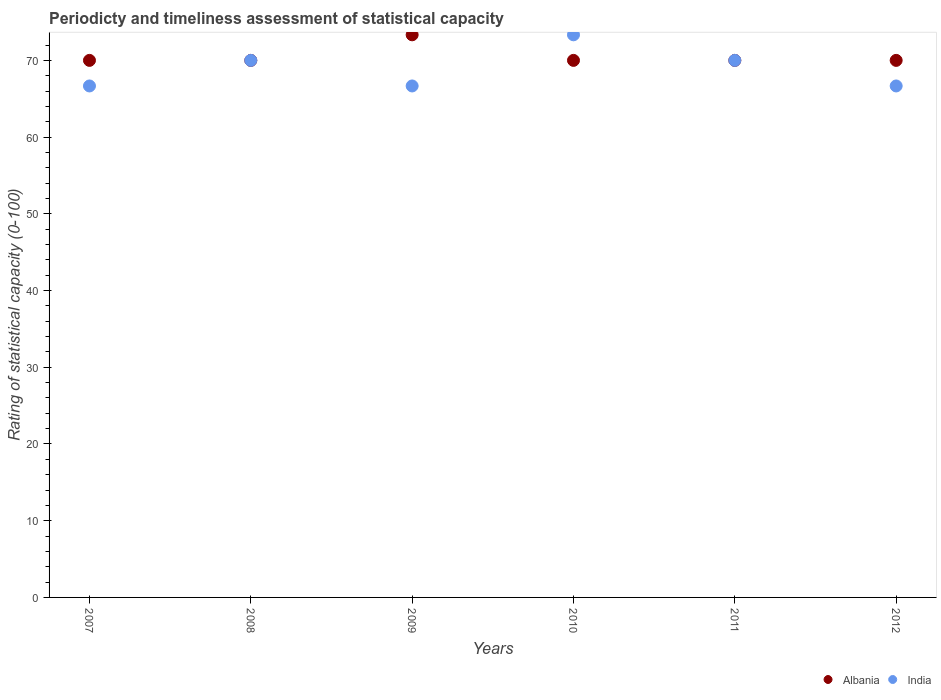Is the number of dotlines equal to the number of legend labels?
Offer a terse response. Yes. What is the rating of statistical capacity in Albania in 2011?
Give a very brief answer. 70. Across all years, what is the maximum rating of statistical capacity in India?
Offer a very short reply. 73.33. What is the total rating of statistical capacity in Albania in the graph?
Make the answer very short. 423.33. What is the difference between the rating of statistical capacity in Albania in 2009 and that in 2010?
Offer a terse response. 3.33. What is the difference between the rating of statistical capacity in Albania in 2012 and the rating of statistical capacity in India in 2009?
Your answer should be compact. 3.33. What is the average rating of statistical capacity in Albania per year?
Make the answer very short. 70.56. In the year 2012, what is the difference between the rating of statistical capacity in India and rating of statistical capacity in Albania?
Ensure brevity in your answer.  -3.33. What is the difference between the highest and the second highest rating of statistical capacity in Albania?
Your answer should be compact. 3.33. What is the difference between the highest and the lowest rating of statistical capacity in India?
Keep it short and to the point. 6.67. In how many years, is the rating of statistical capacity in Albania greater than the average rating of statistical capacity in Albania taken over all years?
Offer a terse response. 1. Is the sum of the rating of statistical capacity in Albania in 2010 and 2011 greater than the maximum rating of statistical capacity in India across all years?
Your answer should be very brief. Yes. Is the rating of statistical capacity in India strictly greater than the rating of statistical capacity in Albania over the years?
Provide a succinct answer. No. How many dotlines are there?
Ensure brevity in your answer.  2. How many years are there in the graph?
Ensure brevity in your answer.  6. What is the difference between two consecutive major ticks on the Y-axis?
Offer a very short reply. 10. Where does the legend appear in the graph?
Your response must be concise. Bottom right. How many legend labels are there?
Your answer should be compact. 2. How are the legend labels stacked?
Your answer should be compact. Horizontal. What is the title of the graph?
Make the answer very short. Periodicty and timeliness assessment of statistical capacity. Does "Zimbabwe" appear as one of the legend labels in the graph?
Provide a short and direct response. No. What is the label or title of the Y-axis?
Ensure brevity in your answer.  Rating of statistical capacity (0-100). What is the Rating of statistical capacity (0-100) in Albania in 2007?
Your answer should be compact. 70. What is the Rating of statistical capacity (0-100) of India in 2007?
Ensure brevity in your answer.  66.67. What is the Rating of statistical capacity (0-100) in India in 2008?
Offer a terse response. 70. What is the Rating of statistical capacity (0-100) in Albania in 2009?
Your response must be concise. 73.33. What is the Rating of statistical capacity (0-100) in India in 2009?
Give a very brief answer. 66.67. What is the Rating of statistical capacity (0-100) in India in 2010?
Make the answer very short. 73.33. What is the Rating of statistical capacity (0-100) of Albania in 2011?
Your response must be concise. 70. What is the Rating of statistical capacity (0-100) of India in 2011?
Provide a short and direct response. 70. What is the Rating of statistical capacity (0-100) of Albania in 2012?
Provide a short and direct response. 70. What is the Rating of statistical capacity (0-100) of India in 2012?
Give a very brief answer. 66.67. Across all years, what is the maximum Rating of statistical capacity (0-100) of Albania?
Make the answer very short. 73.33. Across all years, what is the maximum Rating of statistical capacity (0-100) in India?
Provide a succinct answer. 73.33. Across all years, what is the minimum Rating of statistical capacity (0-100) in India?
Offer a very short reply. 66.67. What is the total Rating of statistical capacity (0-100) in Albania in the graph?
Offer a very short reply. 423.33. What is the total Rating of statistical capacity (0-100) in India in the graph?
Your response must be concise. 413.33. What is the difference between the Rating of statistical capacity (0-100) in Albania in 2007 and that in 2008?
Provide a short and direct response. 0. What is the difference between the Rating of statistical capacity (0-100) in India in 2007 and that in 2008?
Make the answer very short. -3.33. What is the difference between the Rating of statistical capacity (0-100) in Albania in 2007 and that in 2009?
Make the answer very short. -3.33. What is the difference between the Rating of statistical capacity (0-100) in India in 2007 and that in 2009?
Give a very brief answer. 0. What is the difference between the Rating of statistical capacity (0-100) of Albania in 2007 and that in 2010?
Your answer should be compact. 0. What is the difference between the Rating of statistical capacity (0-100) in India in 2007 and that in 2010?
Your answer should be very brief. -6.67. What is the difference between the Rating of statistical capacity (0-100) of Albania in 2007 and that in 2011?
Your answer should be compact. 0. What is the difference between the Rating of statistical capacity (0-100) of Albania in 2007 and that in 2012?
Offer a very short reply. 0. What is the difference between the Rating of statistical capacity (0-100) of India in 2007 and that in 2012?
Your answer should be very brief. 0. What is the difference between the Rating of statistical capacity (0-100) in India in 2008 and that in 2009?
Your answer should be compact. 3.33. What is the difference between the Rating of statistical capacity (0-100) in Albania in 2008 and that in 2011?
Offer a very short reply. 0. What is the difference between the Rating of statistical capacity (0-100) of India in 2008 and that in 2011?
Provide a succinct answer. 0. What is the difference between the Rating of statistical capacity (0-100) of Albania in 2008 and that in 2012?
Ensure brevity in your answer.  0. What is the difference between the Rating of statistical capacity (0-100) of India in 2009 and that in 2010?
Give a very brief answer. -6.67. What is the difference between the Rating of statistical capacity (0-100) of Albania in 2009 and that in 2011?
Give a very brief answer. 3.33. What is the difference between the Rating of statistical capacity (0-100) in India in 2009 and that in 2011?
Offer a very short reply. -3.33. What is the difference between the Rating of statistical capacity (0-100) of Albania in 2009 and that in 2012?
Provide a short and direct response. 3.33. What is the difference between the Rating of statistical capacity (0-100) in India in 2009 and that in 2012?
Provide a short and direct response. 0. What is the difference between the Rating of statistical capacity (0-100) in Albania in 2010 and that in 2012?
Make the answer very short. 0. What is the difference between the Rating of statistical capacity (0-100) in India in 2010 and that in 2012?
Your answer should be compact. 6.67. What is the difference between the Rating of statistical capacity (0-100) in Albania in 2007 and the Rating of statistical capacity (0-100) in India in 2008?
Offer a very short reply. 0. What is the difference between the Rating of statistical capacity (0-100) of Albania in 2007 and the Rating of statistical capacity (0-100) of India in 2009?
Your answer should be very brief. 3.33. What is the difference between the Rating of statistical capacity (0-100) of Albania in 2007 and the Rating of statistical capacity (0-100) of India in 2010?
Offer a terse response. -3.33. What is the difference between the Rating of statistical capacity (0-100) of Albania in 2007 and the Rating of statistical capacity (0-100) of India in 2011?
Your answer should be very brief. 0. What is the difference between the Rating of statistical capacity (0-100) of Albania in 2008 and the Rating of statistical capacity (0-100) of India in 2009?
Your answer should be compact. 3.33. What is the difference between the Rating of statistical capacity (0-100) in Albania in 2008 and the Rating of statistical capacity (0-100) in India in 2010?
Keep it short and to the point. -3.33. What is the difference between the Rating of statistical capacity (0-100) of Albania in 2009 and the Rating of statistical capacity (0-100) of India in 2011?
Your answer should be compact. 3.33. What is the difference between the Rating of statistical capacity (0-100) of Albania in 2010 and the Rating of statistical capacity (0-100) of India in 2012?
Your answer should be compact. 3.33. What is the average Rating of statistical capacity (0-100) in Albania per year?
Offer a very short reply. 70.56. What is the average Rating of statistical capacity (0-100) in India per year?
Ensure brevity in your answer.  68.89. In the year 2007, what is the difference between the Rating of statistical capacity (0-100) in Albania and Rating of statistical capacity (0-100) in India?
Provide a short and direct response. 3.33. In the year 2008, what is the difference between the Rating of statistical capacity (0-100) in Albania and Rating of statistical capacity (0-100) in India?
Offer a terse response. 0. In the year 2009, what is the difference between the Rating of statistical capacity (0-100) of Albania and Rating of statistical capacity (0-100) of India?
Provide a succinct answer. 6.67. In the year 2010, what is the difference between the Rating of statistical capacity (0-100) in Albania and Rating of statistical capacity (0-100) in India?
Offer a terse response. -3.33. In the year 2011, what is the difference between the Rating of statistical capacity (0-100) of Albania and Rating of statistical capacity (0-100) of India?
Keep it short and to the point. 0. In the year 2012, what is the difference between the Rating of statistical capacity (0-100) in Albania and Rating of statistical capacity (0-100) in India?
Your response must be concise. 3.33. What is the ratio of the Rating of statistical capacity (0-100) of India in 2007 to that in 2008?
Your answer should be compact. 0.95. What is the ratio of the Rating of statistical capacity (0-100) in Albania in 2007 to that in 2009?
Your response must be concise. 0.95. What is the ratio of the Rating of statistical capacity (0-100) of Albania in 2007 to that in 2010?
Make the answer very short. 1. What is the ratio of the Rating of statistical capacity (0-100) of Albania in 2007 to that in 2012?
Offer a very short reply. 1. What is the ratio of the Rating of statistical capacity (0-100) in India in 2007 to that in 2012?
Your answer should be compact. 1. What is the ratio of the Rating of statistical capacity (0-100) of Albania in 2008 to that in 2009?
Your response must be concise. 0.95. What is the ratio of the Rating of statistical capacity (0-100) in India in 2008 to that in 2009?
Give a very brief answer. 1.05. What is the ratio of the Rating of statistical capacity (0-100) in India in 2008 to that in 2010?
Keep it short and to the point. 0.95. What is the ratio of the Rating of statistical capacity (0-100) of Albania in 2008 to that in 2011?
Offer a terse response. 1. What is the ratio of the Rating of statistical capacity (0-100) of Albania in 2008 to that in 2012?
Keep it short and to the point. 1. What is the ratio of the Rating of statistical capacity (0-100) in India in 2008 to that in 2012?
Your answer should be compact. 1.05. What is the ratio of the Rating of statistical capacity (0-100) of Albania in 2009 to that in 2010?
Offer a very short reply. 1.05. What is the ratio of the Rating of statistical capacity (0-100) of India in 2009 to that in 2010?
Give a very brief answer. 0.91. What is the ratio of the Rating of statistical capacity (0-100) in Albania in 2009 to that in 2011?
Provide a short and direct response. 1.05. What is the ratio of the Rating of statistical capacity (0-100) in Albania in 2009 to that in 2012?
Your answer should be compact. 1.05. What is the ratio of the Rating of statistical capacity (0-100) in India in 2010 to that in 2011?
Provide a succinct answer. 1.05. What is the ratio of the Rating of statistical capacity (0-100) of Albania in 2010 to that in 2012?
Keep it short and to the point. 1. What is the ratio of the Rating of statistical capacity (0-100) in India in 2010 to that in 2012?
Your response must be concise. 1.1. What is the ratio of the Rating of statistical capacity (0-100) of India in 2011 to that in 2012?
Ensure brevity in your answer.  1.05. What is the difference between the highest and the second highest Rating of statistical capacity (0-100) in India?
Offer a terse response. 3.33. What is the difference between the highest and the lowest Rating of statistical capacity (0-100) in India?
Provide a short and direct response. 6.67. 